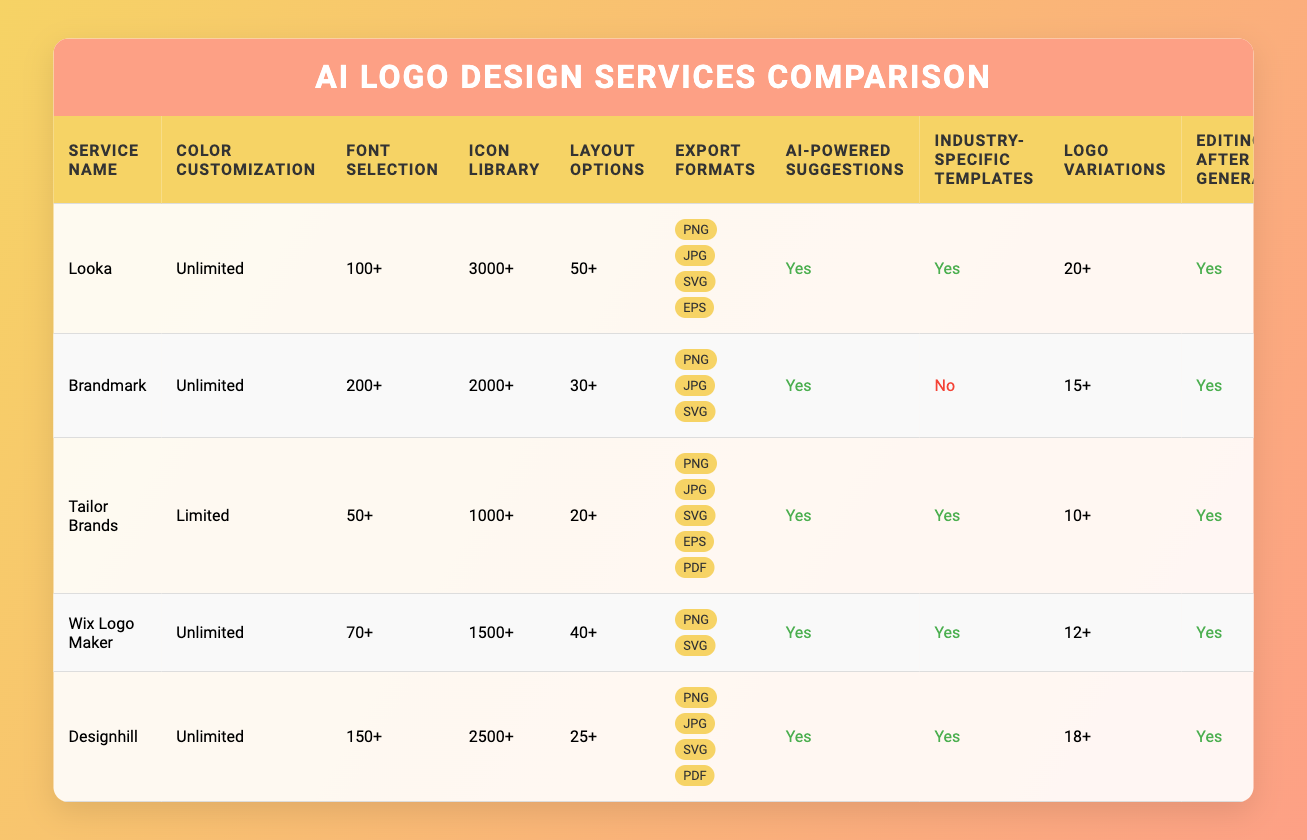What is the maximum number of logo variations available for any service? The maximum number of logo variations is given in the "Logo Variations" column. Looka offers the most with "20+", making it the highest among the listed services.
Answer: 20+ Which service has the largest icon library? In the "Icon Library" column, Looka has "3000+" icons, which is the largest compared to the other services, making it the most rich in icons.
Answer: Looka How many services offer unlimited color customization? By checking the "Color Customization" column, it is clear that Looka, Brandmark, Wix Logo Maker, and Designhill all have "Unlimited," which totals to four services.
Answer: 4 Does Tailor Brands provide industry-specific templates? The "Industry-Specific Templates" column states "Yes" for Tailor Brands, meaning it does provide these templates.
Answer: Yes What is the export format diversity among the services? By analyzing the "Export Formats," we can categorize services based on their offered formats. Looka, Tailor Brands, and Designhill offer four or five formats, whereas Brandmark and Wix Logo Maker have only three, suggesting a variety of export options.
Answer: 4 or 5 formats Which service has the most font selections? Referring to the "Font Selection" column, Brandmark offers "200+" fonts, which is more than any other service.
Answer: Brandmark Is editing after generation available for all services? By looking at the "Editing After Generation" column, all services except the last one provide this feature, indicating that it is available for most options.
Answer: No What is the pricing model for the service with the lowest font selection? The service with the lowest font selection is Tailor Brands, which follows the "Subscription" pricing model as stated in the "Pricing Model" column.
Answer: Subscription Which service does not provide AI-powered suggestions? Inspecting the table reveals that no service lacks AI-powered suggestions; every service confirms that they do offer it, which indicates a robust feature across the board.
Answer: No services lack AI-powered suggestions 